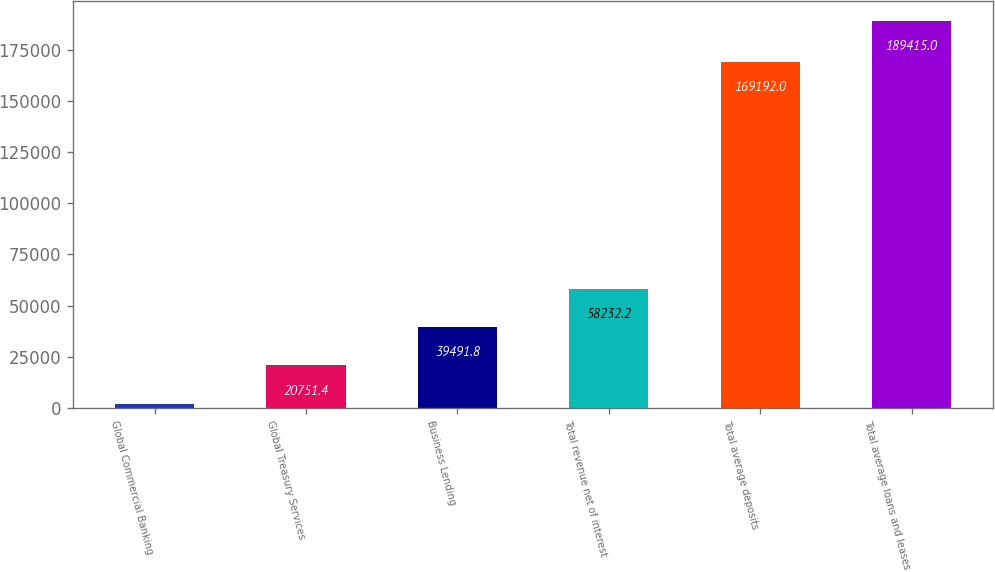Convert chart. <chart><loc_0><loc_0><loc_500><loc_500><bar_chart><fcel>Global Commercial Banking<fcel>Global Treasury Services<fcel>Business Lending<fcel>Total revenue net of interest<fcel>Total average deposits<fcel>Total average loans and leases<nl><fcel>2011<fcel>20751.4<fcel>39491.8<fcel>58232.2<fcel>169192<fcel>189415<nl></chart> 